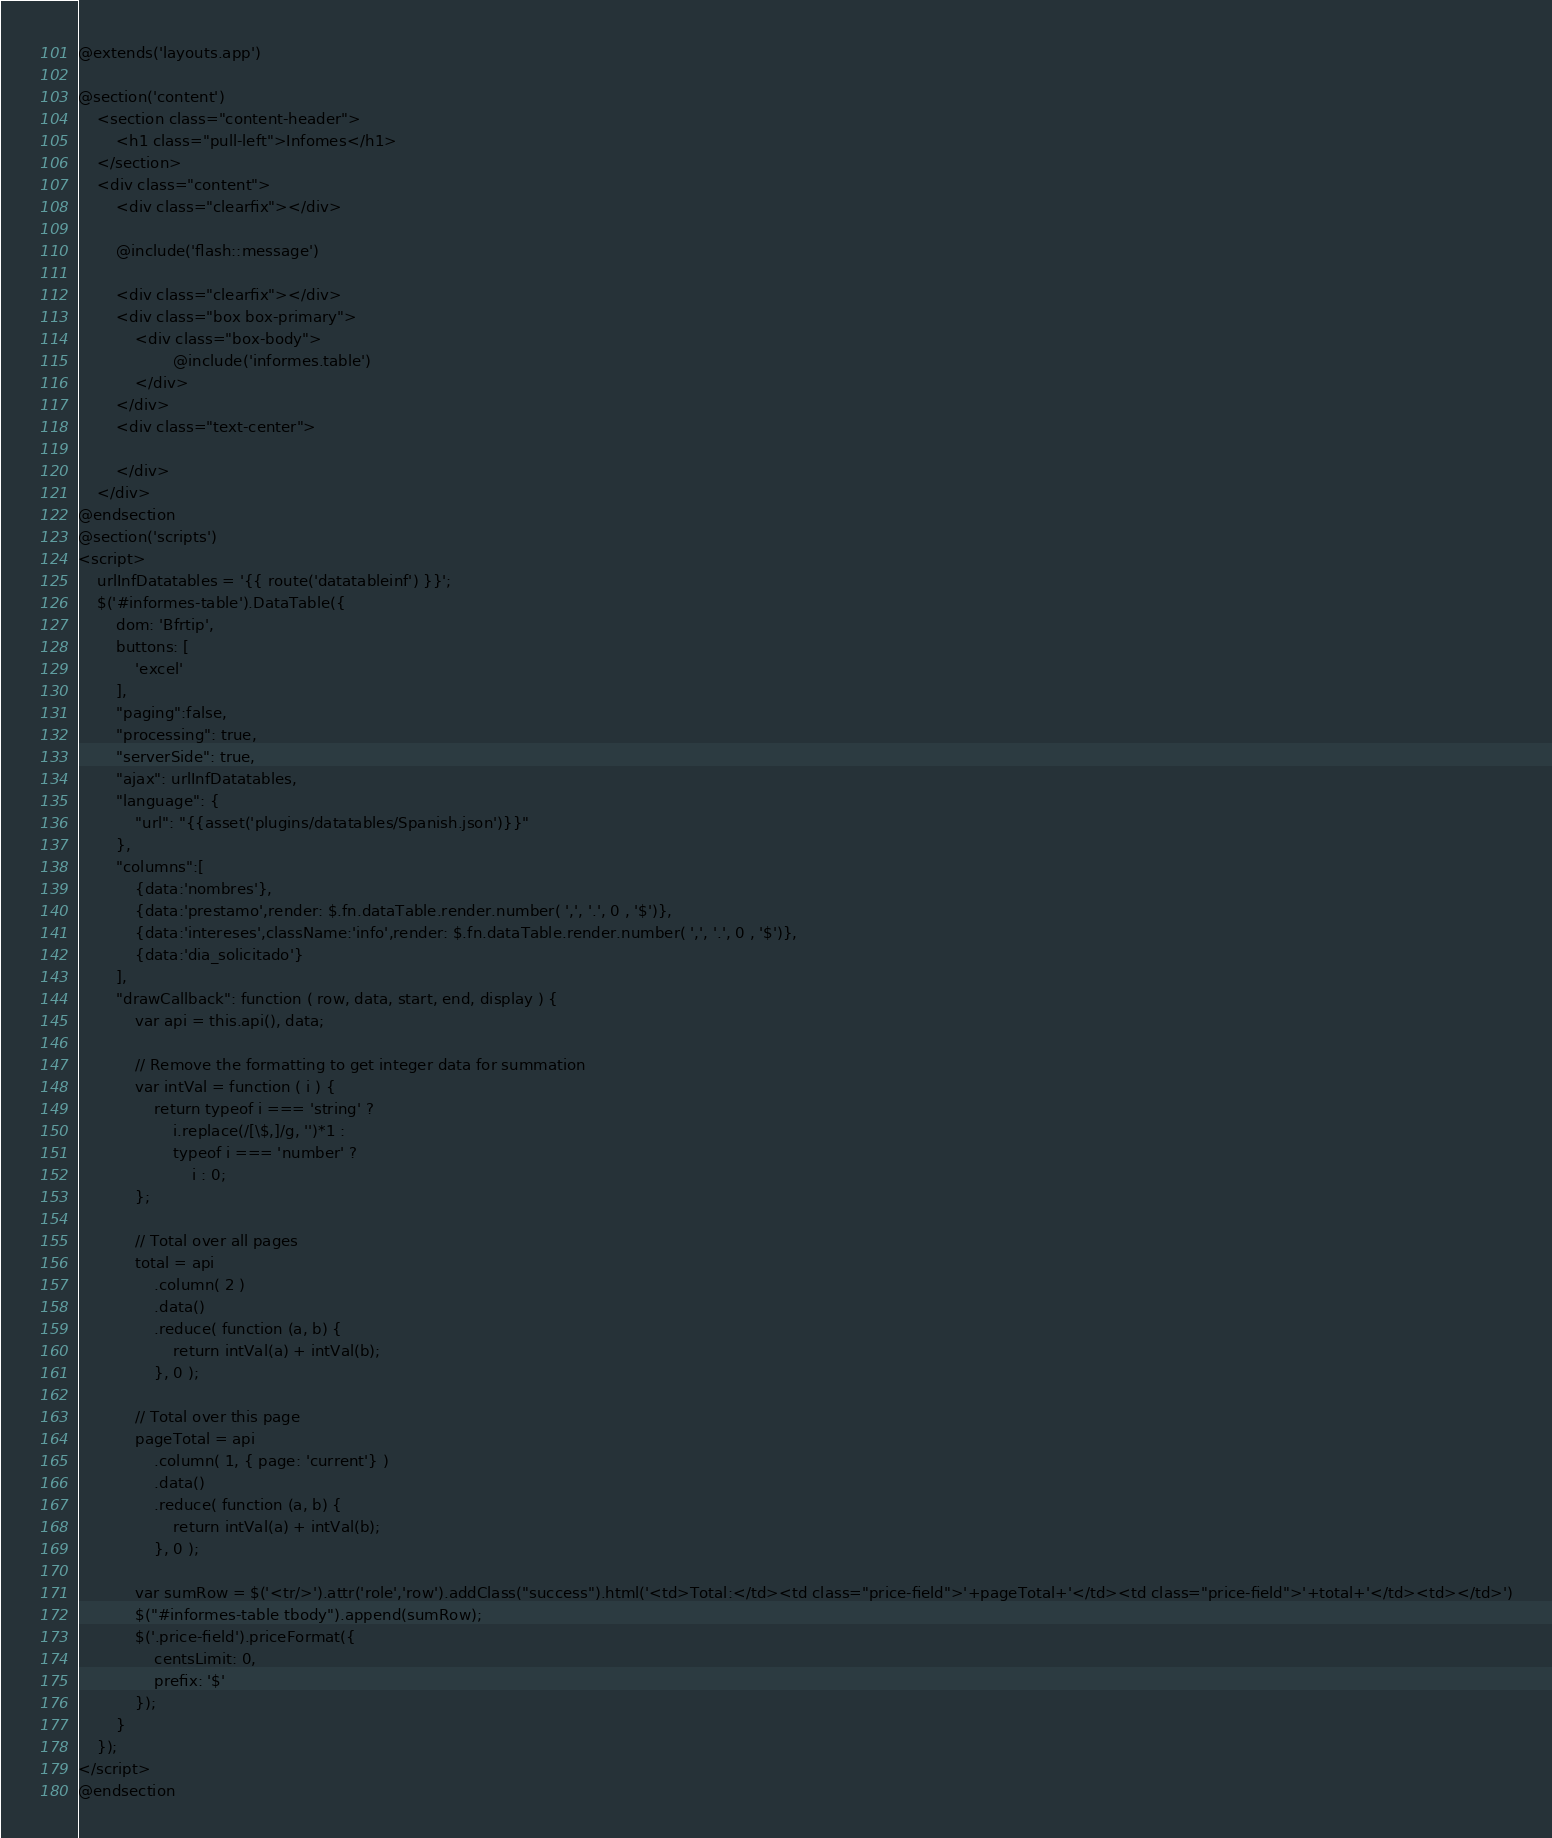<code> <loc_0><loc_0><loc_500><loc_500><_PHP_>@extends('layouts.app')

@section('content')
    <section class="content-header">
        <h1 class="pull-left">Infomes</h1>
    </section>
    <div class="content">
        <div class="clearfix"></div>

        @include('flash::message')

        <div class="clearfix"></div>
        <div class="box box-primary">
            <div class="box-body">
                    @include('informes.table')
            </div>
        </div>
        <div class="text-center">

        </div>
    </div>
@endsection
@section('scripts')
<script>
    urlInfDatatables = '{{ route('datatableinf') }}';
    $('#informes-table').DataTable({
        dom: 'Bfrtip',
        buttons: [
            'excel'
        ],
        "paging":false,
        "processing": true,
        "serverSide": true,
        "ajax": urlInfDatatables,
        "language": {
            "url": "{{asset('plugins/datatables/Spanish.json')}}"
        },
        "columns":[
            {data:'nombres'},
            {data:'prestamo',render: $.fn.dataTable.render.number( ',', '.', 0 , '$')},
            {data:'intereses',className:'info',render: $.fn.dataTable.render.number( ',', '.', 0 , '$')},
            {data:'dia_solicitado'}
        ],
        "drawCallback": function ( row, data, start, end, display ) {
            var api = this.api(), data;
 
            // Remove the formatting to get integer data for summation
            var intVal = function ( i ) {
                return typeof i === 'string' ?
                    i.replace(/[\$,]/g, '')*1 :
                    typeof i === 'number' ?
                        i : 0;
            };
 
            // Total over all pages
            total = api
                .column( 2 )
                .data()
                .reduce( function (a, b) {
                    return intVal(a) + intVal(b);
                }, 0 );
 
            // Total over this page
            pageTotal = api
                .column( 1, { page: 'current'} )
                .data()
                .reduce( function (a, b) {
                    return intVal(a) + intVal(b);
                }, 0 );
 
            var sumRow = $('<tr/>').attr('role','row').addClass("success").html('<td>Total:</td><td class="price-field">'+pageTotal+'</td><td class="price-field">'+total+'</td><td></td>')
            $("#informes-table tbody").append(sumRow);
            $('.price-field').priceFormat({
                centsLimit: 0,
                prefix: '$'
            });
        }
    });
</script>
@endsection
</code> 